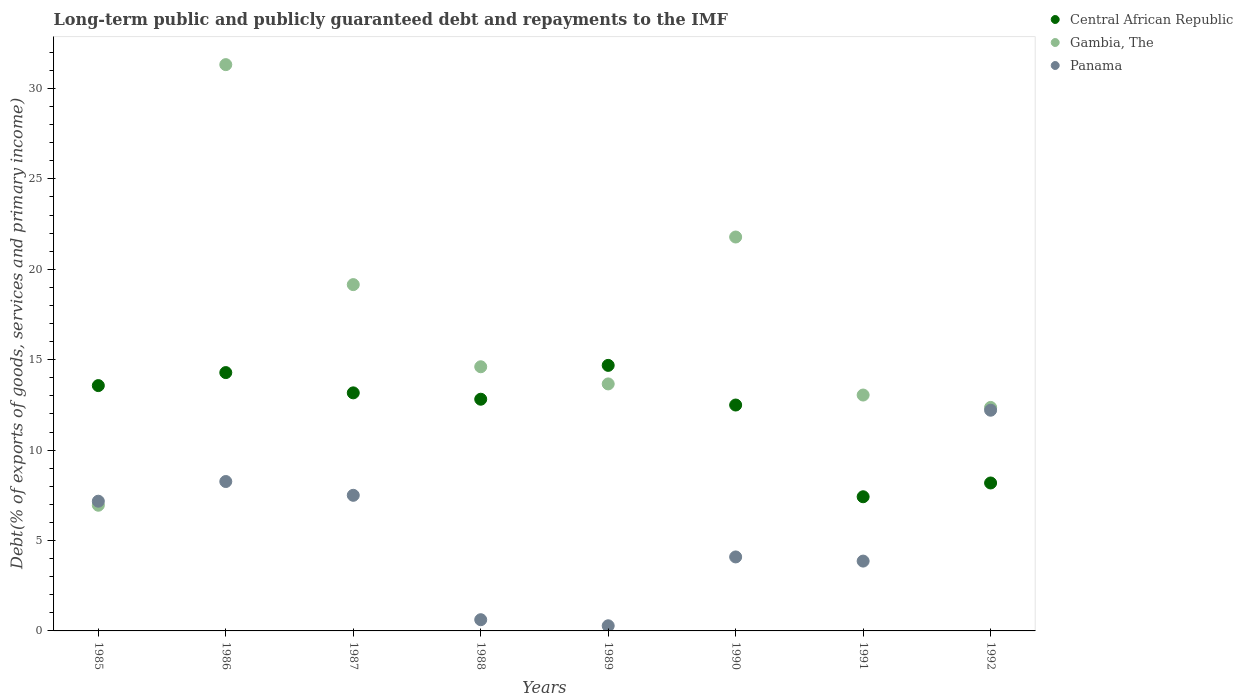What is the debt and repayments in Gambia, The in 1992?
Provide a succinct answer. 12.36. Across all years, what is the maximum debt and repayments in Central African Republic?
Your answer should be very brief. 14.69. Across all years, what is the minimum debt and repayments in Panama?
Make the answer very short. 0.28. In which year was the debt and repayments in Panama maximum?
Your answer should be compact. 1992. In which year was the debt and repayments in Panama minimum?
Provide a short and direct response. 1989. What is the total debt and repayments in Central African Republic in the graph?
Give a very brief answer. 96.62. What is the difference between the debt and repayments in Panama in 1988 and that in 1991?
Offer a terse response. -3.24. What is the difference between the debt and repayments in Central African Republic in 1986 and the debt and repayments in Gambia, The in 1990?
Offer a very short reply. -7.5. What is the average debt and repayments in Panama per year?
Provide a succinct answer. 5.5. In the year 1988, what is the difference between the debt and repayments in Gambia, The and debt and repayments in Central African Republic?
Offer a terse response. 1.79. In how many years, is the debt and repayments in Panama greater than 26 %?
Your answer should be compact. 0. What is the ratio of the debt and repayments in Gambia, The in 1985 to that in 1991?
Provide a short and direct response. 0.53. What is the difference between the highest and the second highest debt and repayments in Central African Republic?
Ensure brevity in your answer.  0.4. What is the difference between the highest and the lowest debt and repayments in Central African Republic?
Your answer should be very brief. 7.27. In how many years, is the debt and repayments in Panama greater than the average debt and repayments in Panama taken over all years?
Offer a terse response. 4. Is the sum of the debt and repayments in Central African Republic in 1985 and 1989 greater than the maximum debt and repayments in Panama across all years?
Your response must be concise. Yes. Is the debt and repayments in Central African Republic strictly greater than the debt and repayments in Panama over the years?
Ensure brevity in your answer.  No. Is the debt and repayments in Panama strictly less than the debt and repayments in Gambia, The over the years?
Keep it short and to the point. No. How many dotlines are there?
Offer a terse response. 3. What is the difference between two consecutive major ticks on the Y-axis?
Provide a succinct answer. 5. Are the values on the major ticks of Y-axis written in scientific E-notation?
Provide a short and direct response. No. Does the graph contain any zero values?
Provide a succinct answer. No. Where does the legend appear in the graph?
Provide a short and direct response. Top right. What is the title of the graph?
Offer a very short reply. Long-term public and publicly guaranteed debt and repayments to the IMF. What is the label or title of the X-axis?
Provide a succinct answer. Years. What is the label or title of the Y-axis?
Make the answer very short. Debt(% of exports of goods, services and primary income). What is the Debt(% of exports of goods, services and primary income) in Central African Republic in 1985?
Your answer should be compact. 13.57. What is the Debt(% of exports of goods, services and primary income) of Gambia, The in 1985?
Your response must be concise. 6.95. What is the Debt(% of exports of goods, services and primary income) in Panama in 1985?
Your answer should be very brief. 7.17. What is the Debt(% of exports of goods, services and primary income) of Central African Republic in 1986?
Ensure brevity in your answer.  14.29. What is the Debt(% of exports of goods, services and primary income) of Gambia, The in 1986?
Make the answer very short. 31.32. What is the Debt(% of exports of goods, services and primary income) of Panama in 1986?
Provide a short and direct response. 8.26. What is the Debt(% of exports of goods, services and primary income) in Central African Republic in 1987?
Keep it short and to the point. 13.17. What is the Debt(% of exports of goods, services and primary income) of Gambia, The in 1987?
Keep it short and to the point. 19.15. What is the Debt(% of exports of goods, services and primary income) in Panama in 1987?
Provide a succinct answer. 7.5. What is the Debt(% of exports of goods, services and primary income) in Central African Republic in 1988?
Your response must be concise. 12.81. What is the Debt(% of exports of goods, services and primary income) in Gambia, The in 1988?
Keep it short and to the point. 14.61. What is the Debt(% of exports of goods, services and primary income) in Panama in 1988?
Ensure brevity in your answer.  0.62. What is the Debt(% of exports of goods, services and primary income) in Central African Republic in 1989?
Offer a terse response. 14.69. What is the Debt(% of exports of goods, services and primary income) of Gambia, The in 1989?
Your answer should be compact. 13.66. What is the Debt(% of exports of goods, services and primary income) of Panama in 1989?
Give a very brief answer. 0.28. What is the Debt(% of exports of goods, services and primary income) of Central African Republic in 1990?
Your response must be concise. 12.49. What is the Debt(% of exports of goods, services and primary income) in Gambia, The in 1990?
Your response must be concise. 21.79. What is the Debt(% of exports of goods, services and primary income) of Panama in 1990?
Your response must be concise. 4.09. What is the Debt(% of exports of goods, services and primary income) of Central African Republic in 1991?
Make the answer very short. 7.42. What is the Debt(% of exports of goods, services and primary income) of Gambia, The in 1991?
Offer a very short reply. 13.05. What is the Debt(% of exports of goods, services and primary income) of Panama in 1991?
Your answer should be very brief. 3.86. What is the Debt(% of exports of goods, services and primary income) of Central African Republic in 1992?
Offer a very short reply. 8.18. What is the Debt(% of exports of goods, services and primary income) of Gambia, The in 1992?
Give a very brief answer. 12.36. What is the Debt(% of exports of goods, services and primary income) in Panama in 1992?
Offer a terse response. 12.21. Across all years, what is the maximum Debt(% of exports of goods, services and primary income) in Central African Republic?
Ensure brevity in your answer.  14.69. Across all years, what is the maximum Debt(% of exports of goods, services and primary income) in Gambia, The?
Make the answer very short. 31.32. Across all years, what is the maximum Debt(% of exports of goods, services and primary income) in Panama?
Your response must be concise. 12.21. Across all years, what is the minimum Debt(% of exports of goods, services and primary income) in Central African Republic?
Give a very brief answer. 7.42. Across all years, what is the minimum Debt(% of exports of goods, services and primary income) of Gambia, The?
Your answer should be very brief. 6.95. Across all years, what is the minimum Debt(% of exports of goods, services and primary income) of Panama?
Your answer should be very brief. 0.28. What is the total Debt(% of exports of goods, services and primary income) of Central African Republic in the graph?
Ensure brevity in your answer.  96.62. What is the total Debt(% of exports of goods, services and primary income) of Gambia, The in the graph?
Provide a short and direct response. 132.88. What is the total Debt(% of exports of goods, services and primary income) in Panama in the graph?
Make the answer very short. 44. What is the difference between the Debt(% of exports of goods, services and primary income) in Central African Republic in 1985 and that in 1986?
Your answer should be compact. -0.72. What is the difference between the Debt(% of exports of goods, services and primary income) in Gambia, The in 1985 and that in 1986?
Your answer should be very brief. -24.37. What is the difference between the Debt(% of exports of goods, services and primary income) of Panama in 1985 and that in 1986?
Offer a terse response. -1.09. What is the difference between the Debt(% of exports of goods, services and primary income) of Central African Republic in 1985 and that in 1987?
Keep it short and to the point. 0.4. What is the difference between the Debt(% of exports of goods, services and primary income) of Gambia, The in 1985 and that in 1987?
Give a very brief answer. -12.2. What is the difference between the Debt(% of exports of goods, services and primary income) of Panama in 1985 and that in 1987?
Your answer should be compact. -0.33. What is the difference between the Debt(% of exports of goods, services and primary income) in Central African Republic in 1985 and that in 1988?
Offer a terse response. 0.75. What is the difference between the Debt(% of exports of goods, services and primary income) of Gambia, The in 1985 and that in 1988?
Give a very brief answer. -7.66. What is the difference between the Debt(% of exports of goods, services and primary income) in Panama in 1985 and that in 1988?
Your answer should be compact. 6.55. What is the difference between the Debt(% of exports of goods, services and primary income) in Central African Republic in 1985 and that in 1989?
Your answer should be compact. -1.12. What is the difference between the Debt(% of exports of goods, services and primary income) in Gambia, The in 1985 and that in 1989?
Your answer should be compact. -6.71. What is the difference between the Debt(% of exports of goods, services and primary income) of Panama in 1985 and that in 1989?
Your response must be concise. 6.89. What is the difference between the Debt(% of exports of goods, services and primary income) in Central African Republic in 1985 and that in 1990?
Offer a terse response. 1.07. What is the difference between the Debt(% of exports of goods, services and primary income) of Gambia, The in 1985 and that in 1990?
Offer a terse response. -14.83. What is the difference between the Debt(% of exports of goods, services and primary income) of Panama in 1985 and that in 1990?
Keep it short and to the point. 3.08. What is the difference between the Debt(% of exports of goods, services and primary income) of Central African Republic in 1985 and that in 1991?
Your answer should be very brief. 6.15. What is the difference between the Debt(% of exports of goods, services and primary income) in Gambia, The in 1985 and that in 1991?
Offer a very short reply. -6.09. What is the difference between the Debt(% of exports of goods, services and primary income) of Panama in 1985 and that in 1991?
Your response must be concise. 3.31. What is the difference between the Debt(% of exports of goods, services and primary income) of Central African Republic in 1985 and that in 1992?
Your response must be concise. 5.39. What is the difference between the Debt(% of exports of goods, services and primary income) in Gambia, The in 1985 and that in 1992?
Your answer should be very brief. -5.41. What is the difference between the Debt(% of exports of goods, services and primary income) in Panama in 1985 and that in 1992?
Your answer should be very brief. -5.03. What is the difference between the Debt(% of exports of goods, services and primary income) in Central African Republic in 1986 and that in 1987?
Provide a short and direct response. 1.12. What is the difference between the Debt(% of exports of goods, services and primary income) of Gambia, The in 1986 and that in 1987?
Provide a short and direct response. 12.17. What is the difference between the Debt(% of exports of goods, services and primary income) of Panama in 1986 and that in 1987?
Offer a terse response. 0.76. What is the difference between the Debt(% of exports of goods, services and primary income) in Central African Republic in 1986 and that in 1988?
Offer a very short reply. 1.47. What is the difference between the Debt(% of exports of goods, services and primary income) in Gambia, The in 1986 and that in 1988?
Provide a short and direct response. 16.71. What is the difference between the Debt(% of exports of goods, services and primary income) of Panama in 1986 and that in 1988?
Offer a very short reply. 7.64. What is the difference between the Debt(% of exports of goods, services and primary income) of Central African Republic in 1986 and that in 1989?
Provide a short and direct response. -0.4. What is the difference between the Debt(% of exports of goods, services and primary income) of Gambia, The in 1986 and that in 1989?
Your response must be concise. 17.66. What is the difference between the Debt(% of exports of goods, services and primary income) of Panama in 1986 and that in 1989?
Keep it short and to the point. 7.98. What is the difference between the Debt(% of exports of goods, services and primary income) in Central African Republic in 1986 and that in 1990?
Make the answer very short. 1.79. What is the difference between the Debt(% of exports of goods, services and primary income) of Gambia, The in 1986 and that in 1990?
Keep it short and to the point. 9.53. What is the difference between the Debt(% of exports of goods, services and primary income) of Panama in 1986 and that in 1990?
Provide a short and direct response. 4.17. What is the difference between the Debt(% of exports of goods, services and primary income) in Central African Republic in 1986 and that in 1991?
Make the answer very short. 6.87. What is the difference between the Debt(% of exports of goods, services and primary income) in Gambia, The in 1986 and that in 1991?
Keep it short and to the point. 18.27. What is the difference between the Debt(% of exports of goods, services and primary income) in Panama in 1986 and that in 1991?
Give a very brief answer. 4.4. What is the difference between the Debt(% of exports of goods, services and primary income) of Central African Republic in 1986 and that in 1992?
Give a very brief answer. 6.11. What is the difference between the Debt(% of exports of goods, services and primary income) in Gambia, The in 1986 and that in 1992?
Keep it short and to the point. 18.96. What is the difference between the Debt(% of exports of goods, services and primary income) of Panama in 1986 and that in 1992?
Ensure brevity in your answer.  -3.94. What is the difference between the Debt(% of exports of goods, services and primary income) of Central African Republic in 1987 and that in 1988?
Give a very brief answer. 0.35. What is the difference between the Debt(% of exports of goods, services and primary income) in Gambia, The in 1987 and that in 1988?
Make the answer very short. 4.54. What is the difference between the Debt(% of exports of goods, services and primary income) of Panama in 1987 and that in 1988?
Provide a short and direct response. 6.88. What is the difference between the Debt(% of exports of goods, services and primary income) in Central African Republic in 1987 and that in 1989?
Give a very brief answer. -1.52. What is the difference between the Debt(% of exports of goods, services and primary income) in Gambia, The in 1987 and that in 1989?
Provide a short and direct response. 5.49. What is the difference between the Debt(% of exports of goods, services and primary income) in Panama in 1987 and that in 1989?
Provide a short and direct response. 7.22. What is the difference between the Debt(% of exports of goods, services and primary income) of Central African Republic in 1987 and that in 1990?
Keep it short and to the point. 0.67. What is the difference between the Debt(% of exports of goods, services and primary income) in Gambia, The in 1987 and that in 1990?
Provide a succinct answer. -2.63. What is the difference between the Debt(% of exports of goods, services and primary income) in Panama in 1987 and that in 1990?
Give a very brief answer. 3.41. What is the difference between the Debt(% of exports of goods, services and primary income) in Central African Republic in 1987 and that in 1991?
Your response must be concise. 5.75. What is the difference between the Debt(% of exports of goods, services and primary income) in Gambia, The in 1987 and that in 1991?
Provide a succinct answer. 6.11. What is the difference between the Debt(% of exports of goods, services and primary income) in Panama in 1987 and that in 1991?
Provide a succinct answer. 3.64. What is the difference between the Debt(% of exports of goods, services and primary income) in Central African Republic in 1987 and that in 1992?
Your answer should be compact. 4.98. What is the difference between the Debt(% of exports of goods, services and primary income) in Gambia, The in 1987 and that in 1992?
Your answer should be compact. 6.79. What is the difference between the Debt(% of exports of goods, services and primary income) of Panama in 1987 and that in 1992?
Keep it short and to the point. -4.71. What is the difference between the Debt(% of exports of goods, services and primary income) in Central African Republic in 1988 and that in 1989?
Keep it short and to the point. -1.87. What is the difference between the Debt(% of exports of goods, services and primary income) of Gambia, The in 1988 and that in 1989?
Give a very brief answer. 0.95. What is the difference between the Debt(% of exports of goods, services and primary income) in Panama in 1988 and that in 1989?
Ensure brevity in your answer.  0.34. What is the difference between the Debt(% of exports of goods, services and primary income) in Central African Republic in 1988 and that in 1990?
Make the answer very short. 0.32. What is the difference between the Debt(% of exports of goods, services and primary income) in Gambia, The in 1988 and that in 1990?
Your answer should be very brief. -7.18. What is the difference between the Debt(% of exports of goods, services and primary income) of Panama in 1988 and that in 1990?
Ensure brevity in your answer.  -3.47. What is the difference between the Debt(% of exports of goods, services and primary income) of Central African Republic in 1988 and that in 1991?
Ensure brevity in your answer.  5.39. What is the difference between the Debt(% of exports of goods, services and primary income) in Gambia, The in 1988 and that in 1991?
Provide a short and direct response. 1.56. What is the difference between the Debt(% of exports of goods, services and primary income) of Panama in 1988 and that in 1991?
Your response must be concise. -3.24. What is the difference between the Debt(% of exports of goods, services and primary income) in Central African Republic in 1988 and that in 1992?
Make the answer very short. 4.63. What is the difference between the Debt(% of exports of goods, services and primary income) of Gambia, The in 1988 and that in 1992?
Ensure brevity in your answer.  2.25. What is the difference between the Debt(% of exports of goods, services and primary income) of Panama in 1988 and that in 1992?
Provide a succinct answer. -11.59. What is the difference between the Debt(% of exports of goods, services and primary income) of Central African Republic in 1989 and that in 1990?
Your answer should be very brief. 2.19. What is the difference between the Debt(% of exports of goods, services and primary income) in Gambia, The in 1989 and that in 1990?
Provide a short and direct response. -8.12. What is the difference between the Debt(% of exports of goods, services and primary income) of Panama in 1989 and that in 1990?
Keep it short and to the point. -3.81. What is the difference between the Debt(% of exports of goods, services and primary income) of Central African Republic in 1989 and that in 1991?
Ensure brevity in your answer.  7.27. What is the difference between the Debt(% of exports of goods, services and primary income) of Gambia, The in 1989 and that in 1991?
Ensure brevity in your answer.  0.61. What is the difference between the Debt(% of exports of goods, services and primary income) of Panama in 1989 and that in 1991?
Provide a short and direct response. -3.58. What is the difference between the Debt(% of exports of goods, services and primary income) of Central African Republic in 1989 and that in 1992?
Give a very brief answer. 6.5. What is the difference between the Debt(% of exports of goods, services and primary income) of Gambia, The in 1989 and that in 1992?
Offer a terse response. 1.3. What is the difference between the Debt(% of exports of goods, services and primary income) in Panama in 1989 and that in 1992?
Your answer should be very brief. -11.92. What is the difference between the Debt(% of exports of goods, services and primary income) in Central African Republic in 1990 and that in 1991?
Your response must be concise. 5.07. What is the difference between the Debt(% of exports of goods, services and primary income) in Gambia, The in 1990 and that in 1991?
Offer a terse response. 8.74. What is the difference between the Debt(% of exports of goods, services and primary income) of Panama in 1990 and that in 1991?
Provide a succinct answer. 0.23. What is the difference between the Debt(% of exports of goods, services and primary income) of Central African Republic in 1990 and that in 1992?
Give a very brief answer. 4.31. What is the difference between the Debt(% of exports of goods, services and primary income) in Gambia, The in 1990 and that in 1992?
Your answer should be compact. 9.43. What is the difference between the Debt(% of exports of goods, services and primary income) of Panama in 1990 and that in 1992?
Make the answer very short. -8.11. What is the difference between the Debt(% of exports of goods, services and primary income) in Central African Republic in 1991 and that in 1992?
Offer a terse response. -0.76. What is the difference between the Debt(% of exports of goods, services and primary income) in Gambia, The in 1991 and that in 1992?
Keep it short and to the point. 0.69. What is the difference between the Debt(% of exports of goods, services and primary income) of Panama in 1991 and that in 1992?
Keep it short and to the point. -8.34. What is the difference between the Debt(% of exports of goods, services and primary income) of Central African Republic in 1985 and the Debt(% of exports of goods, services and primary income) of Gambia, The in 1986?
Give a very brief answer. -17.75. What is the difference between the Debt(% of exports of goods, services and primary income) of Central African Republic in 1985 and the Debt(% of exports of goods, services and primary income) of Panama in 1986?
Make the answer very short. 5.31. What is the difference between the Debt(% of exports of goods, services and primary income) of Gambia, The in 1985 and the Debt(% of exports of goods, services and primary income) of Panama in 1986?
Your answer should be very brief. -1.31. What is the difference between the Debt(% of exports of goods, services and primary income) of Central African Republic in 1985 and the Debt(% of exports of goods, services and primary income) of Gambia, The in 1987?
Your answer should be compact. -5.58. What is the difference between the Debt(% of exports of goods, services and primary income) in Central African Republic in 1985 and the Debt(% of exports of goods, services and primary income) in Panama in 1987?
Give a very brief answer. 6.07. What is the difference between the Debt(% of exports of goods, services and primary income) of Gambia, The in 1985 and the Debt(% of exports of goods, services and primary income) of Panama in 1987?
Provide a short and direct response. -0.55. What is the difference between the Debt(% of exports of goods, services and primary income) in Central African Republic in 1985 and the Debt(% of exports of goods, services and primary income) in Gambia, The in 1988?
Your answer should be very brief. -1.04. What is the difference between the Debt(% of exports of goods, services and primary income) in Central African Republic in 1985 and the Debt(% of exports of goods, services and primary income) in Panama in 1988?
Your response must be concise. 12.95. What is the difference between the Debt(% of exports of goods, services and primary income) in Gambia, The in 1985 and the Debt(% of exports of goods, services and primary income) in Panama in 1988?
Your answer should be very brief. 6.33. What is the difference between the Debt(% of exports of goods, services and primary income) in Central African Republic in 1985 and the Debt(% of exports of goods, services and primary income) in Gambia, The in 1989?
Your response must be concise. -0.09. What is the difference between the Debt(% of exports of goods, services and primary income) of Central African Republic in 1985 and the Debt(% of exports of goods, services and primary income) of Panama in 1989?
Make the answer very short. 13.28. What is the difference between the Debt(% of exports of goods, services and primary income) of Gambia, The in 1985 and the Debt(% of exports of goods, services and primary income) of Panama in 1989?
Your answer should be very brief. 6.67. What is the difference between the Debt(% of exports of goods, services and primary income) in Central African Republic in 1985 and the Debt(% of exports of goods, services and primary income) in Gambia, The in 1990?
Offer a very short reply. -8.22. What is the difference between the Debt(% of exports of goods, services and primary income) of Central African Republic in 1985 and the Debt(% of exports of goods, services and primary income) of Panama in 1990?
Provide a short and direct response. 9.48. What is the difference between the Debt(% of exports of goods, services and primary income) of Gambia, The in 1985 and the Debt(% of exports of goods, services and primary income) of Panama in 1990?
Provide a short and direct response. 2.86. What is the difference between the Debt(% of exports of goods, services and primary income) in Central African Republic in 1985 and the Debt(% of exports of goods, services and primary income) in Gambia, The in 1991?
Offer a very short reply. 0.52. What is the difference between the Debt(% of exports of goods, services and primary income) of Central African Republic in 1985 and the Debt(% of exports of goods, services and primary income) of Panama in 1991?
Ensure brevity in your answer.  9.71. What is the difference between the Debt(% of exports of goods, services and primary income) of Gambia, The in 1985 and the Debt(% of exports of goods, services and primary income) of Panama in 1991?
Your answer should be very brief. 3.09. What is the difference between the Debt(% of exports of goods, services and primary income) of Central African Republic in 1985 and the Debt(% of exports of goods, services and primary income) of Gambia, The in 1992?
Your response must be concise. 1.21. What is the difference between the Debt(% of exports of goods, services and primary income) in Central African Republic in 1985 and the Debt(% of exports of goods, services and primary income) in Panama in 1992?
Offer a terse response. 1.36. What is the difference between the Debt(% of exports of goods, services and primary income) in Gambia, The in 1985 and the Debt(% of exports of goods, services and primary income) in Panama in 1992?
Provide a short and direct response. -5.25. What is the difference between the Debt(% of exports of goods, services and primary income) of Central African Republic in 1986 and the Debt(% of exports of goods, services and primary income) of Gambia, The in 1987?
Offer a very short reply. -4.87. What is the difference between the Debt(% of exports of goods, services and primary income) of Central African Republic in 1986 and the Debt(% of exports of goods, services and primary income) of Panama in 1987?
Provide a short and direct response. 6.79. What is the difference between the Debt(% of exports of goods, services and primary income) in Gambia, The in 1986 and the Debt(% of exports of goods, services and primary income) in Panama in 1987?
Your answer should be compact. 23.82. What is the difference between the Debt(% of exports of goods, services and primary income) in Central African Republic in 1986 and the Debt(% of exports of goods, services and primary income) in Gambia, The in 1988?
Ensure brevity in your answer.  -0.32. What is the difference between the Debt(% of exports of goods, services and primary income) of Central African Republic in 1986 and the Debt(% of exports of goods, services and primary income) of Panama in 1988?
Your answer should be compact. 13.67. What is the difference between the Debt(% of exports of goods, services and primary income) in Gambia, The in 1986 and the Debt(% of exports of goods, services and primary income) in Panama in 1988?
Your answer should be very brief. 30.7. What is the difference between the Debt(% of exports of goods, services and primary income) in Central African Republic in 1986 and the Debt(% of exports of goods, services and primary income) in Gambia, The in 1989?
Provide a succinct answer. 0.63. What is the difference between the Debt(% of exports of goods, services and primary income) of Central African Republic in 1986 and the Debt(% of exports of goods, services and primary income) of Panama in 1989?
Ensure brevity in your answer.  14. What is the difference between the Debt(% of exports of goods, services and primary income) in Gambia, The in 1986 and the Debt(% of exports of goods, services and primary income) in Panama in 1989?
Make the answer very short. 31.03. What is the difference between the Debt(% of exports of goods, services and primary income) of Central African Republic in 1986 and the Debt(% of exports of goods, services and primary income) of Gambia, The in 1990?
Make the answer very short. -7.5. What is the difference between the Debt(% of exports of goods, services and primary income) of Central African Republic in 1986 and the Debt(% of exports of goods, services and primary income) of Panama in 1990?
Your answer should be very brief. 10.2. What is the difference between the Debt(% of exports of goods, services and primary income) of Gambia, The in 1986 and the Debt(% of exports of goods, services and primary income) of Panama in 1990?
Offer a terse response. 27.23. What is the difference between the Debt(% of exports of goods, services and primary income) of Central African Republic in 1986 and the Debt(% of exports of goods, services and primary income) of Gambia, The in 1991?
Provide a short and direct response. 1.24. What is the difference between the Debt(% of exports of goods, services and primary income) of Central African Republic in 1986 and the Debt(% of exports of goods, services and primary income) of Panama in 1991?
Provide a short and direct response. 10.43. What is the difference between the Debt(% of exports of goods, services and primary income) of Gambia, The in 1986 and the Debt(% of exports of goods, services and primary income) of Panama in 1991?
Make the answer very short. 27.46. What is the difference between the Debt(% of exports of goods, services and primary income) of Central African Republic in 1986 and the Debt(% of exports of goods, services and primary income) of Gambia, The in 1992?
Provide a succinct answer. 1.93. What is the difference between the Debt(% of exports of goods, services and primary income) in Central African Republic in 1986 and the Debt(% of exports of goods, services and primary income) in Panama in 1992?
Give a very brief answer. 2.08. What is the difference between the Debt(% of exports of goods, services and primary income) of Gambia, The in 1986 and the Debt(% of exports of goods, services and primary income) of Panama in 1992?
Offer a terse response. 19.11. What is the difference between the Debt(% of exports of goods, services and primary income) of Central African Republic in 1987 and the Debt(% of exports of goods, services and primary income) of Gambia, The in 1988?
Give a very brief answer. -1.44. What is the difference between the Debt(% of exports of goods, services and primary income) of Central African Republic in 1987 and the Debt(% of exports of goods, services and primary income) of Panama in 1988?
Provide a succinct answer. 12.55. What is the difference between the Debt(% of exports of goods, services and primary income) in Gambia, The in 1987 and the Debt(% of exports of goods, services and primary income) in Panama in 1988?
Ensure brevity in your answer.  18.53. What is the difference between the Debt(% of exports of goods, services and primary income) in Central African Republic in 1987 and the Debt(% of exports of goods, services and primary income) in Gambia, The in 1989?
Provide a short and direct response. -0.49. What is the difference between the Debt(% of exports of goods, services and primary income) in Central African Republic in 1987 and the Debt(% of exports of goods, services and primary income) in Panama in 1989?
Your answer should be compact. 12.88. What is the difference between the Debt(% of exports of goods, services and primary income) in Gambia, The in 1987 and the Debt(% of exports of goods, services and primary income) in Panama in 1989?
Your answer should be compact. 18.87. What is the difference between the Debt(% of exports of goods, services and primary income) of Central African Republic in 1987 and the Debt(% of exports of goods, services and primary income) of Gambia, The in 1990?
Ensure brevity in your answer.  -8.62. What is the difference between the Debt(% of exports of goods, services and primary income) of Central African Republic in 1987 and the Debt(% of exports of goods, services and primary income) of Panama in 1990?
Your response must be concise. 9.07. What is the difference between the Debt(% of exports of goods, services and primary income) in Gambia, The in 1987 and the Debt(% of exports of goods, services and primary income) in Panama in 1990?
Your answer should be compact. 15.06. What is the difference between the Debt(% of exports of goods, services and primary income) of Central African Republic in 1987 and the Debt(% of exports of goods, services and primary income) of Gambia, The in 1991?
Provide a succinct answer. 0.12. What is the difference between the Debt(% of exports of goods, services and primary income) of Central African Republic in 1987 and the Debt(% of exports of goods, services and primary income) of Panama in 1991?
Keep it short and to the point. 9.3. What is the difference between the Debt(% of exports of goods, services and primary income) of Gambia, The in 1987 and the Debt(% of exports of goods, services and primary income) of Panama in 1991?
Offer a terse response. 15.29. What is the difference between the Debt(% of exports of goods, services and primary income) of Central African Republic in 1987 and the Debt(% of exports of goods, services and primary income) of Gambia, The in 1992?
Make the answer very short. 0.81. What is the difference between the Debt(% of exports of goods, services and primary income) in Central African Republic in 1987 and the Debt(% of exports of goods, services and primary income) in Panama in 1992?
Your answer should be compact. 0.96. What is the difference between the Debt(% of exports of goods, services and primary income) of Gambia, The in 1987 and the Debt(% of exports of goods, services and primary income) of Panama in 1992?
Provide a short and direct response. 6.95. What is the difference between the Debt(% of exports of goods, services and primary income) in Central African Republic in 1988 and the Debt(% of exports of goods, services and primary income) in Gambia, The in 1989?
Offer a terse response. -0.85. What is the difference between the Debt(% of exports of goods, services and primary income) of Central African Republic in 1988 and the Debt(% of exports of goods, services and primary income) of Panama in 1989?
Provide a short and direct response. 12.53. What is the difference between the Debt(% of exports of goods, services and primary income) in Gambia, The in 1988 and the Debt(% of exports of goods, services and primary income) in Panama in 1989?
Your answer should be very brief. 14.32. What is the difference between the Debt(% of exports of goods, services and primary income) in Central African Republic in 1988 and the Debt(% of exports of goods, services and primary income) in Gambia, The in 1990?
Ensure brevity in your answer.  -8.97. What is the difference between the Debt(% of exports of goods, services and primary income) of Central African Republic in 1988 and the Debt(% of exports of goods, services and primary income) of Panama in 1990?
Make the answer very short. 8.72. What is the difference between the Debt(% of exports of goods, services and primary income) of Gambia, The in 1988 and the Debt(% of exports of goods, services and primary income) of Panama in 1990?
Provide a succinct answer. 10.52. What is the difference between the Debt(% of exports of goods, services and primary income) in Central African Republic in 1988 and the Debt(% of exports of goods, services and primary income) in Gambia, The in 1991?
Offer a very short reply. -0.23. What is the difference between the Debt(% of exports of goods, services and primary income) of Central African Republic in 1988 and the Debt(% of exports of goods, services and primary income) of Panama in 1991?
Ensure brevity in your answer.  8.95. What is the difference between the Debt(% of exports of goods, services and primary income) in Gambia, The in 1988 and the Debt(% of exports of goods, services and primary income) in Panama in 1991?
Offer a terse response. 10.75. What is the difference between the Debt(% of exports of goods, services and primary income) of Central African Republic in 1988 and the Debt(% of exports of goods, services and primary income) of Gambia, The in 1992?
Your answer should be compact. 0.45. What is the difference between the Debt(% of exports of goods, services and primary income) in Central African Republic in 1988 and the Debt(% of exports of goods, services and primary income) in Panama in 1992?
Your response must be concise. 0.61. What is the difference between the Debt(% of exports of goods, services and primary income) of Gambia, The in 1988 and the Debt(% of exports of goods, services and primary income) of Panama in 1992?
Your answer should be compact. 2.4. What is the difference between the Debt(% of exports of goods, services and primary income) in Central African Republic in 1989 and the Debt(% of exports of goods, services and primary income) in Gambia, The in 1990?
Give a very brief answer. -7.1. What is the difference between the Debt(% of exports of goods, services and primary income) of Central African Republic in 1989 and the Debt(% of exports of goods, services and primary income) of Panama in 1990?
Ensure brevity in your answer.  10.59. What is the difference between the Debt(% of exports of goods, services and primary income) in Gambia, The in 1989 and the Debt(% of exports of goods, services and primary income) in Panama in 1990?
Your answer should be compact. 9.57. What is the difference between the Debt(% of exports of goods, services and primary income) in Central African Republic in 1989 and the Debt(% of exports of goods, services and primary income) in Gambia, The in 1991?
Your answer should be very brief. 1.64. What is the difference between the Debt(% of exports of goods, services and primary income) of Central African Republic in 1989 and the Debt(% of exports of goods, services and primary income) of Panama in 1991?
Ensure brevity in your answer.  10.82. What is the difference between the Debt(% of exports of goods, services and primary income) of Gambia, The in 1989 and the Debt(% of exports of goods, services and primary income) of Panama in 1991?
Ensure brevity in your answer.  9.8. What is the difference between the Debt(% of exports of goods, services and primary income) of Central African Republic in 1989 and the Debt(% of exports of goods, services and primary income) of Gambia, The in 1992?
Give a very brief answer. 2.33. What is the difference between the Debt(% of exports of goods, services and primary income) of Central African Republic in 1989 and the Debt(% of exports of goods, services and primary income) of Panama in 1992?
Your answer should be compact. 2.48. What is the difference between the Debt(% of exports of goods, services and primary income) in Gambia, The in 1989 and the Debt(% of exports of goods, services and primary income) in Panama in 1992?
Provide a succinct answer. 1.45. What is the difference between the Debt(% of exports of goods, services and primary income) in Central African Republic in 1990 and the Debt(% of exports of goods, services and primary income) in Gambia, The in 1991?
Your answer should be very brief. -0.55. What is the difference between the Debt(% of exports of goods, services and primary income) of Central African Republic in 1990 and the Debt(% of exports of goods, services and primary income) of Panama in 1991?
Your answer should be compact. 8.63. What is the difference between the Debt(% of exports of goods, services and primary income) of Gambia, The in 1990 and the Debt(% of exports of goods, services and primary income) of Panama in 1991?
Your answer should be very brief. 17.92. What is the difference between the Debt(% of exports of goods, services and primary income) in Central African Republic in 1990 and the Debt(% of exports of goods, services and primary income) in Gambia, The in 1992?
Provide a short and direct response. 0.13. What is the difference between the Debt(% of exports of goods, services and primary income) in Central African Republic in 1990 and the Debt(% of exports of goods, services and primary income) in Panama in 1992?
Offer a terse response. 0.29. What is the difference between the Debt(% of exports of goods, services and primary income) of Gambia, The in 1990 and the Debt(% of exports of goods, services and primary income) of Panama in 1992?
Make the answer very short. 9.58. What is the difference between the Debt(% of exports of goods, services and primary income) in Central African Republic in 1991 and the Debt(% of exports of goods, services and primary income) in Gambia, The in 1992?
Provide a short and direct response. -4.94. What is the difference between the Debt(% of exports of goods, services and primary income) in Central African Republic in 1991 and the Debt(% of exports of goods, services and primary income) in Panama in 1992?
Give a very brief answer. -4.79. What is the difference between the Debt(% of exports of goods, services and primary income) of Gambia, The in 1991 and the Debt(% of exports of goods, services and primary income) of Panama in 1992?
Ensure brevity in your answer.  0.84. What is the average Debt(% of exports of goods, services and primary income) in Central African Republic per year?
Give a very brief answer. 12.08. What is the average Debt(% of exports of goods, services and primary income) in Gambia, The per year?
Offer a terse response. 16.61. What is the average Debt(% of exports of goods, services and primary income) in Panama per year?
Your answer should be very brief. 5.5. In the year 1985, what is the difference between the Debt(% of exports of goods, services and primary income) in Central African Republic and Debt(% of exports of goods, services and primary income) in Gambia, The?
Make the answer very short. 6.62. In the year 1985, what is the difference between the Debt(% of exports of goods, services and primary income) in Central African Republic and Debt(% of exports of goods, services and primary income) in Panama?
Keep it short and to the point. 6.39. In the year 1985, what is the difference between the Debt(% of exports of goods, services and primary income) of Gambia, The and Debt(% of exports of goods, services and primary income) of Panama?
Offer a very short reply. -0.22. In the year 1986, what is the difference between the Debt(% of exports of goods, services and primary income) of Central African Republic and Debt(% of exports of goods, services and primary income) of Gambia, The?
Your answer should be very brief. -17.03. In the year 1986, what is the difference between the Debt(% of exports of goods, services and primary income) of Central African Republic and Debt(% of exports of goods, services and primary income) of Panama?
Provide a succinct answer. 6.02. In the year 1986, what is the difference between the Debt(% of exports of goods, services and primary income) in Gambia, The and Debt(% of exports of goods, services and primary income) in Panama?
Keep it short and to the point. 23.06. In the year 1987, what is the difference between the Debt(% of exports of goods, services and primary income) of Central African Republic and Debt(% of exports of goods, services and primary income) of Gambia, The?
Your answer should be compact. -5.99. In the year 1987, what is the difference between the Debt(% of exports of goods, services and primary income) in Central African Republic and Debt(% of exports of goods, services and primary income) in Panama?
Your response must be concise. 5.67. In the year 1987, what is the difference between the Debt(% of exports of goods, services and primary income) in Gambia, The and Debt(% of exports of goods, services and primary income) in Panama?
Provide a short and direct response. 11.65. In the year 1988, what is the difference between the Debt(% of exports of goods, services and primary income) in Central African Republic and Debt(% of exports of goods, services and primary income) in Gambia, The?
Your response must be concise. -1.79. In the year 1988, what is the difference between the Debt(% of exports of goods, services and primary income) in Central African Republic and Debt(% of exports of goods, services and primary income) in Panama?
Give a very brief answer. 12.19. In the year 1988, what is the difference between the Debt(% of exports of goods, services and primary income) in Gambia, The and Debt(% of exports of goods, services and primary income) in Panama?
Ensure brevity in your answer.  13.99. In the year 1989, what is the difference between the Debt(% of exports of goods, services and primary income) in Central African Republic and Debt(% of exports of goods, services and primary income) in Gambia, The?
Ensure brevity in your answer.  1.03. In the year 1989, what is the difference between the Debt(% of exports of goods, services and primary income) of Central African Republic and Debt(% of exports of goods, services and primary income) of Panama?
Offer a very short reply. 14.4. In the year 1989, what is the difference between the Debt(% of exports of goods, services and primary income) of Gambia, The and Debt(% of exports of goods, services and primary income) of Panama?
Offer a terse response. 13.38. In the year 1990, what is the difference between the Debt(% of exports of goods, services and primary income) in Central African Republic and Debt(% of exports of goods, services and primary income) in Gambia, The?
Your response must be concise. -9.29. In the year 1990, what is the difference between the Debt(% of exports of goods, services and primary income) in Central African Republic and Debt(% of exports of goods, services and primary income) in Panama?
Your answer should be very brief. 8.4. In the year 1990, what is the difference between the Debt(% of exports of goods, services and primary income) of Gambia, The and Debt(% of exports of goods, services and primary income) of Panama?
Keep it short and to the point. 17.69. In the year 1991, what is the difference between the Debt(% of exports of goods, services and primary income) of Central African Republic and Debt(% of exports of goods, services and primary income) of Gambia, The?
Give a very brief answer. -5.63. In the year 1991, what is the difference between the Debt(% of exports of goods, services and primary income) of Central African Republic and Debt(% of exports of goods, services and primary income) of Panama?
Ensure brevity in your answer.  3.56. In the year 1991, what is the difference between the Debt(% of exports of goods, services and primary income) in Gambia, The and Debt(% of exports of goods, services and primary income) in Panama?
Your response must be concise. 9.18. In the year 1992, what is the difference between the Debt(% of exports of goods, services and primary income) of Central African Republic and Debt(% of exports of goods, services and primary income) of Gambia, The?
Provide a short and direct response. -4.18. In the year 1992, what is the difference between the Debt(% of exports of goods, services and primary income) in Central African Republic and Debt(% of exports of goods, services and primary income) in Panama?
Offer a terse response. -4.02. In the year 1992, what is the difference between the Debt(% of exports of goods, services and primary income) of Gambia, The and Debt(% of exports of goods, services and primary income) of Panama?
Provide a succinct answer. 0.15. What is the ratio of the Debt(% of exports of goods, services and primary income) in Central African Republic in 1985 to that in 1986?
Give a very brief answer. 0.95. What is the ratio of the Debt(% of exports of goods, services and primary income) of Gambia, The in 1985 to that in 1986?
Your answer should be compact. 0.22. What is the ratio of the Debt(% of exports of goods, services and primary income) in Panama in 1985 to that in 1986?
Your answer should be very brief. 0.87. What is the ratio of the Debt(% of exports of goods, services and primary income) of Central African Republic in 1985 to that in 1987?
Provide a succinct answer. 1.03. What is the ratio of the Debt(% of exports of goods, services and primary income) in Gambia, The in 1985 to that in 1987?
Offer a terse response. 0.36. What is the ratio of the Debt(% of exports of goods, services and primary income) of Panama in 1985 to that in 1987?
Offer a terse response. 0.96. What is the ratio of the Debt(% of exports of goods, services and primary income) in Central African Republic in 1985 to that in 1988?
Your answer should be compact. 1.06. What is the ratio of the Debt(% of exports of goods, services and primary income) of Gambia, The in 1985 to that in 1988?
Ensure brevity in your answer.  0.48. What is the ratio of the Debt(% of exports of goods, services and primary income) in Panama in 1985 to that in 1988?
Offer a terse response. 11.57. What is the ratio of the Debt(% of exports of goods, services and primary income) of Central African Republic in 1985 to that in 1989?
Your response must be concise. 0.92. What is the ratio of the Debt(% of exports of goods, services and primary income) in Gambia, The in 1985 to that in 1989?
Your answer should be compact. 0.51. What is the ratio of the Debt(% of exports of goods, services and primary income) in Panama in 1985 to that in 1989?
Keep it short and to the point. 25.22. What is the ratio of the Debt(% of exports of goods, services and primary income) in Central African Republic in 1985 to that in 1990?
Your answer should be very brief. 1.09. What is the ratio of the Debt(% of exports of goods, services and primary income) in Gambia, The in 1985 to that in 1990?
Ensure brevity in your answer.  0.32. What is the ratio of the Debt(% of exports of goods, services and primary income) of Panama in 1985 to that in 1990?
Give a very brief answer. 1.75. What is the ratio of the Debt(% of exports of goods, services and primary income) of Central African Republic in 1985 to that in 1991?
Keep it short and to the point. 1.83. What is the ratio of the Debt(% of exports of goods, services and primary income) in Gambia, The in 1985 to that in 1991?
Your answer should be compact. 0.53. What is the ratio of the Debt(% of exports of goods, services and primary income) in Panama in 1985 to that in 1991?
Ensure brevity in your answer.  1.86. What is the ratio of the Debt(% of exports of goods, services and primary income) in Central African Republic in 1985 to that in 1992?
Ensure brevity in your answer.  1.66. What is the ratio of the Debt(% of exports of goods, services and primary income) in Gambia, The in 1985 to that in 1992?
Your answer should be very brief. 0.56. What is the ratio of the Debt(% of exports of goods, services and primary income) in Panama in 1985 to that in 1992?
Provide a succinct answer. 0.59. What is the ratio of the Debt(% of exports of goods, services and primary income) of Central African Republic in 1986 to that in 1987?
Your response must be concise. 1.09. What is the ratio of the Debt(% of exports of goods, services and primary income) in Gambia, The in 1986 to that in 1987?
Ensure brevity in your answer.  1.64. What is the ratio of the Debt(% of exports of goods, services and primary income) of Panama in 1986 to that in 1987?
Provide a short and direct response. 1.1. What is the ratio of the Debt(% of exports of goods, services and primary income) of Central African Republic in 1986 to that in 1988?
Offer a terse response. 1.11. What is the ratio of the Debt(% of exports of goods, services and primary income) in Gambia, The in 1986 to that in 1988?
Give a very brief answer. 2.14. What is the ratio of the Debt(% of exports of goods, services and primary income) in Panama in 1986 to that in 1988?
Give a very brief answer. 13.33. What is the ratio of the Debt(% of exports of goods, services and primary income) in Central African Republic in 1986 to that in 1989?
Give a very brief answer. 0.97. What is the ratio of the Debt(% of exports of goods, services and primary income) in Gambia, The in 1986 to that in 1989?
Provide a succinct answer. 2.29. What is the ratio of the Debt(% of exports of goods, services and primary income) in Panama in 1986 to that in 1989?
Offer a terse response. 29.05. What is the ratio of the Debt(% of exports of goods, services and primary income) of Central African Republic in 1986 to that in 1990?
Your answer should be very brief. 1.14. What is the ratio of the Debt(% of exports of goods, services and primary income) of Gambia, The in 1986 to that in 1990?
Keep it short and to the point. 1.44. What is the ratio of the Debt(% of exports of goods, services and primary income) of Panama in 1986 to that in 1990?
Your answer should be compact. 2.02. What is the ratio of the Debt(% of exports of goods, services and primary income) of Central African Republic in 1986 to that in 1991?
Your answer should be very brief. 1.93. What is the ratio of the Debt(% of exports of goods, services and primary income) of Gambia, The in 1986 to that in 1991?
Your response must be concise. 2.4. What is the ratio of the Debt(% of exports of goods, services and primary income) in Panama in 1986 to that in 1991?
Make the answer very short. 2.14. What is the ratio of the Debt(% of exports of goods, services and primary income) in Central African Republic in 1986 to that in 1992?
Provide a short and direct response. 1.75. What is the ratio of the Debt(% of exports of goods, services and primary income) of Gambia, The in 1986 to that in 1992?
Provide a short and direct response. 2.53. What is the ratio of the Debt(% of exports of goods, services and primary income) in Panama in 1986 to that in 1992?
Provide a short and direct response. 0.68. What is the ratio of the Debt(% of exports of goods, services and primary income) of Central African Republic in 1987 to that in 1988?
Keep it short and to the point. 1.03. What is the ratio of the Debt(% of exports of goods, services and primary income) in Gambia, The in 1987 to that in 1988?
Offer a very short reply. 1.31. What is the ratio of the Debt(% of exports of goods, services and primary income) in Panama in 1987 to that in 1988?
Offer a very short reply. 12.1. What is the ratio of the Debt(% of exports of goods, services and primary income) of Central African Republic in 1987 to that in 1989?
Offer a very short reply. 0.9. What is the ratio of the Debt(% of exports of goods, services and primary income) in Gambia, The in 1987 to that in 1989?
Ensure brevity in your answer.  1.4. What is the ratio of the Debt(% of exports of goods, services and primary income) of Panama in 1987 to that in 1989?
Your answer should be very brief. 26.37. What is the ratio of the Debt(% of exports of goods, services and primary income) of Central African Republic in 1987 to that in 1990?
Provide a succinct answer. 1.05. What is the ratio of the Debt(% of exports of goods, services and primary income) of Gambia, The in 1987 to that in 1990?
Give a very brief answer. 0.88. What is the ratio of the Debt(% of exports of goods, services and primary income) of Panama in 1987 to that in 1990?
Make the answer very short. 1.83. What is the ratio of the Debt(% of exports of goods, services and primary income) in Central African Republic in 1987 to that in 1991?
Make the answer very short. 1.77. What is the ratio of the Debt(% of exports of goods, services and primary income) in Gambia, The in 1987 to that in 1991?
Give a very brief answer. 1.47. What is the ratio of the Debt(% of exports of goods, services and primary income) in Panama in 1987 to that in 1991?
Ensure brevity in your answer.  1.94. What is the ratio of the Debt(% of exports of goods, services and primary income) of Central African Republic in 1987 to that in 1992?
Offer a terse response. 1.61. What is the ratio of the Debt(% of exports of goods, services and primary income) of Gambia, The in 1987 to that in 1992?
Your answer should be very brief. 1.55. What is the ratio of the Debt(% of exports of goods, services and primary income) in Panama in 1987 to that in 1992?
Your answer should be compact. 0.61. What is the ratio of the Debt(% of exports of goods, services and primary income) of Central African Republic in 1988 to that in 1989?
Offer a terse response. 0.87. What is the ratio of the Debt(% of exports of goods, services and primary income) in Gambia, The in 1988 to that in 1989?
Offer a terse response. 1.07. What is the ratio of the Debt(% of exports of goods, services and primary income) of Panama in 1988 to that in 1989?
Provide a short and direct response. 2.18. What is the ratio of the Debt(% of exports of goods, services and primary income) of Central African Republic in 1988 to that in 1990?
Ensure brevity in your answer.  1.03. What is the ratio of the Debt(% of exports of goods, services and primary income) of Gambia, The in 1988 to that in 1990?
Your answer should be compact. 0.67. What is the ratio of the Debt(% of exports of goods, services and primary income) of Panama in 1988 to that in 1990?
Offer a very short reply. 0.15. What is the ratio of the Debt(% of exports of goods, services and primary income) of Central African Republic in 1988 to that in 1991?
Your answer should be compact. 1.73. What is the ratio of the Debt(% of exports of goods, services and primary income) of Gambia, The in 1988 to that in 1991?
Your response must be concise. 1.12. What is the ratio of the Debt(% of exports of goods, services and primary income) of Panama in 1988 to that in 1991?
Provide a short and direct response. 0.16. What is the ratio of the Debt(% of exports of goods, services and primary income) in Central African Republic in 1988 to that in 1992?
Your answer should be very brief. 1.57. What is the ratio of the Debt(% of exports of goods, services and primary income) in Gambia, The in 1988 to that in 1992?
Offer a terse response. 1.18. What is the ratio of the Debt(% of exports of goods, services and primary income) in Panama in 1988 to that in 1992?
Make the answer very short. 0.05. What is the ratio of the Debt(% of exports of goods, services and primary income) in Central African Republic in 1989 to that in 1990?
Your response must be concise. 1.18. What is the ratio of the Debt(% of exports of goods, services and primary income) of Gambia, The in 1989 to that in 1990?
Give a very brief answer. 0.63. What is the ratio of the Debt(% of exports of goods, services and primary income) in Panama in 1989 to that in 1990?
Offer a terse response. 0.07. What is the ratio of the Debt(% of exports of goods, services and primary income) in Central African Republic in 1989 to that in 1991?
Your answer should be very brief. 1.98. What is the ratio of the Debt(% of exports of goods, services and primary income) of Gambia, The in 1989 to that in 1991?
Keep it short and to the point. 1.05. What is the ratio of the Debt(% of exports of goods, services and primary income) of Panama in 1989 to that in 1991?
Ensure brevity in your answer.  0.07. What is the ratio of the Debt(% of exports of goods, services and primary income) of Central African Republic in 1989 to that in 1992?
Offer a terse response. 1.79. What is the ratio of the Debt(% of exports of goods, services and primary income) in Gambia, The in 1989 to that in 1992?
Provide a succinct answer. 1.11. What is the ratio of the Debt(% of exports of goods, services and primary income) in Panama in 1989 to that in 1992?
Offer a terse response. 0.02. What is the ratio of the Debt(% of exports of goods, services and primary income) of Central African Republic in 1990 to that in 1991?
Your answer should be compact. 1.68. What is the ratio of the Debt(% of exports of goods, services and primary income) in Gambia, The in 1990 to that in 1991?
Offer a terse response. 1.67. What is the ratio of the Debt(% of exports of goods, services and primary income) of Panama in 1990 to that in 1991?
Your answer should be very brief. 1.06. What is the ratio of the Debt(% of exports of goods, services and primary income) of Central African Republic in 1990 to that in 1992?
Your response must be concise. 1.53. What is the ratio of the Debt(% of exports of goods, services and primary income) of Gambia, The in 1990 to that in 1992?
Offer a terse response. 1.76. What is the ratio of the Debt(% of exports of goods, services and primary income) in Panama in 1990 to that in 1992?
Your answer should be very brief. 0.34. What is the ratio of the Debt(% of exports of goods, services and primary income) in Central African Republic in 1991 to that in 1992?
Give a very brief answer. 0.91. What is the ratio of the Debt(% of exports of goods, services and primary income) in Gambia, The in 1991 to that in 1992?
Offer a terse response. 1.06. What is the ratio of the Debt(% of exports of goods, services and primary income) of Panama in 1991 to that in 1992?
Give a very brief answer. 0.32. What is the difference between the highest and the second highest Debt(% of exports of goods, services and primary income) of Central African Republic?
Offer a terse response. 0.4. What is the difference between the highest and the second highest Debt(% of exports of goods, services and primary income) in Gambia, The?
Your answer should be very brief. 9.53. What is the difference between the highest and the second highest Debt(% of exports of goods, services and primary income) in Panama?
Provide a short and direct response. 3.94. What is the difference between the highest and the lowest Debt(% of exports of goods, services and primary income) of Central African Republic?
Make the answer very short. 7.27. What is the difference between the highest and the lowest Debt(% of exports of goods, services and primary income) in Gambia, The?
Ensure brevity in your answer.  24.37. What is the difference between the highest and the lowest Debt(% of exports of goods, services and primary income) of Panama?
Ensure brevity in your answer.  11.92. 